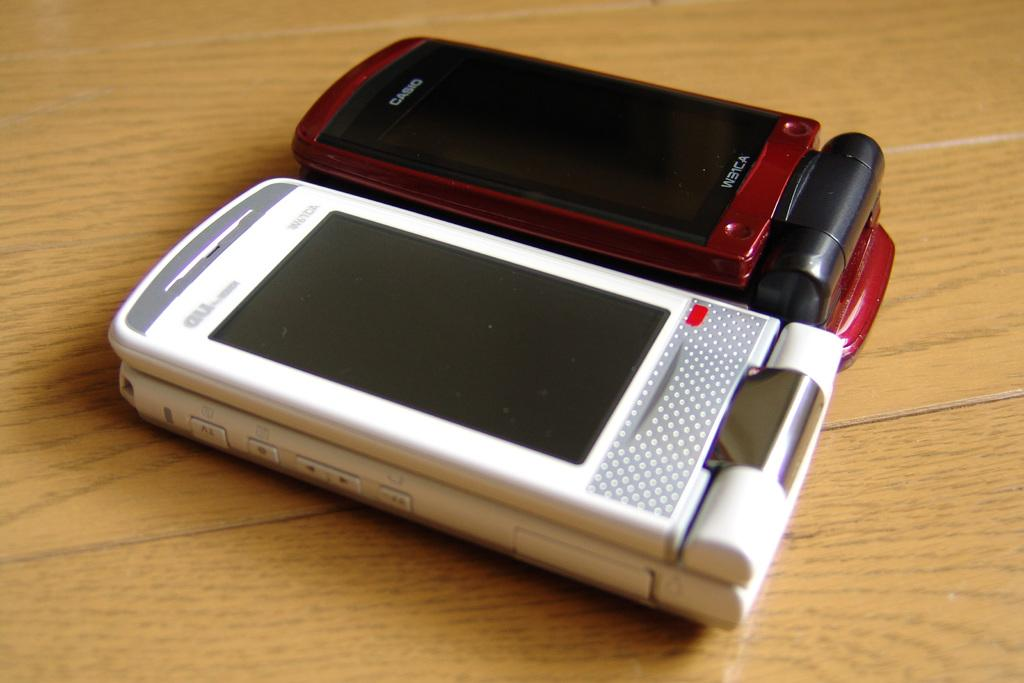<image>
Present a compact description of the photo's key features. Two flip phones, one a red Casio and one white, sit side by side on a table. 